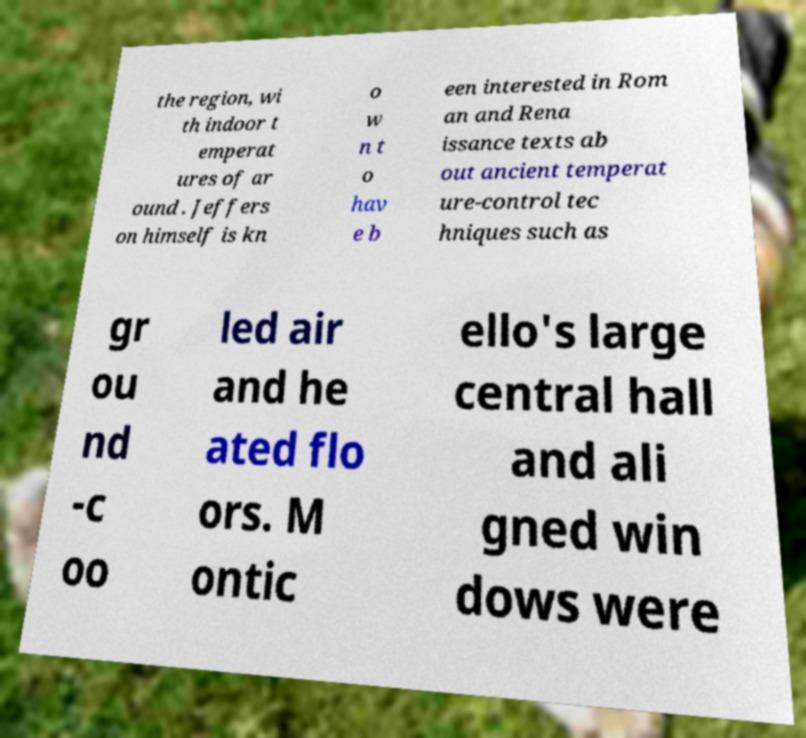Please identify and transcribe the text found in this image. the region, wi th indoor t emperat ures of ar ound . Jeffers on himself is kn o w n t o hav e b een interested in Rom an and Rena issance texts ab out ancient temperat ure-control tec hniques such as gr ou nd -c oo led air and he ated flo ors. M ontic ello's large central hall and ali gned win dows were 